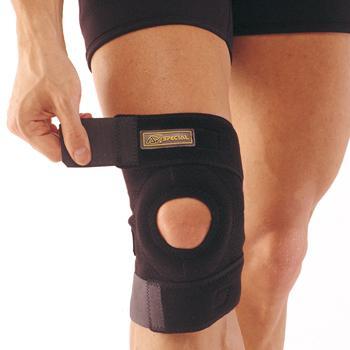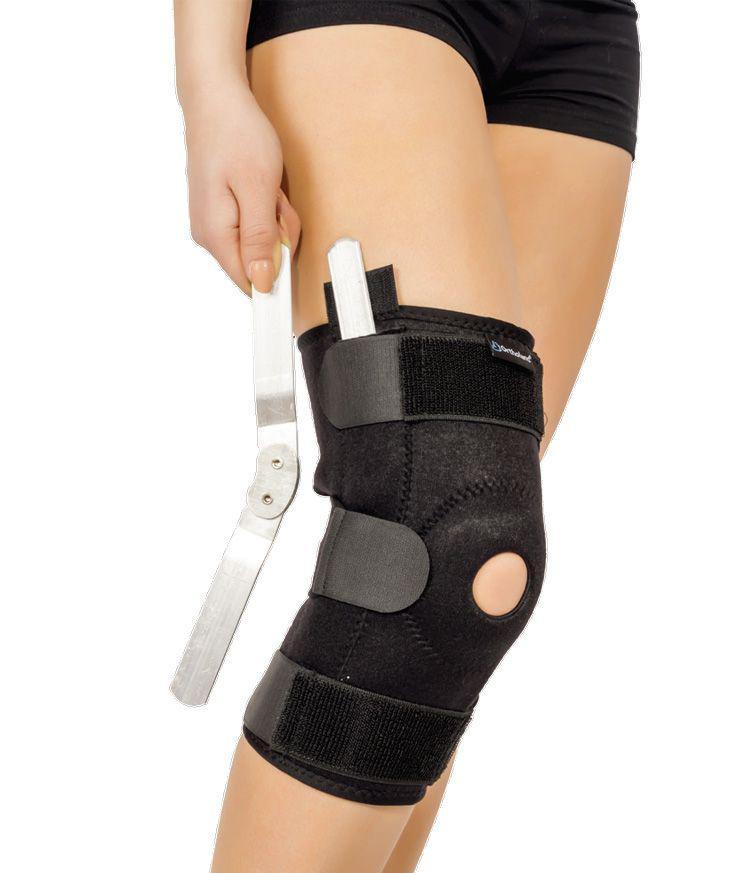The first image is the image on the left, the second image is the image on the right. For the images displayed, is the sentence "One black kneepad with a round knee hole is in each image, one of them being adjusted by a person using two hands." factually correct? Answer yes or no. No. The first image is the image on the left, the second image is the image on the right. Evaluate the accuracy of this statement regarding the images: "One image shows a hand on the left holding something next to a black knee pad worn on a leg next to a bare leg.". Is it true? Answer yes or no. Yes. 